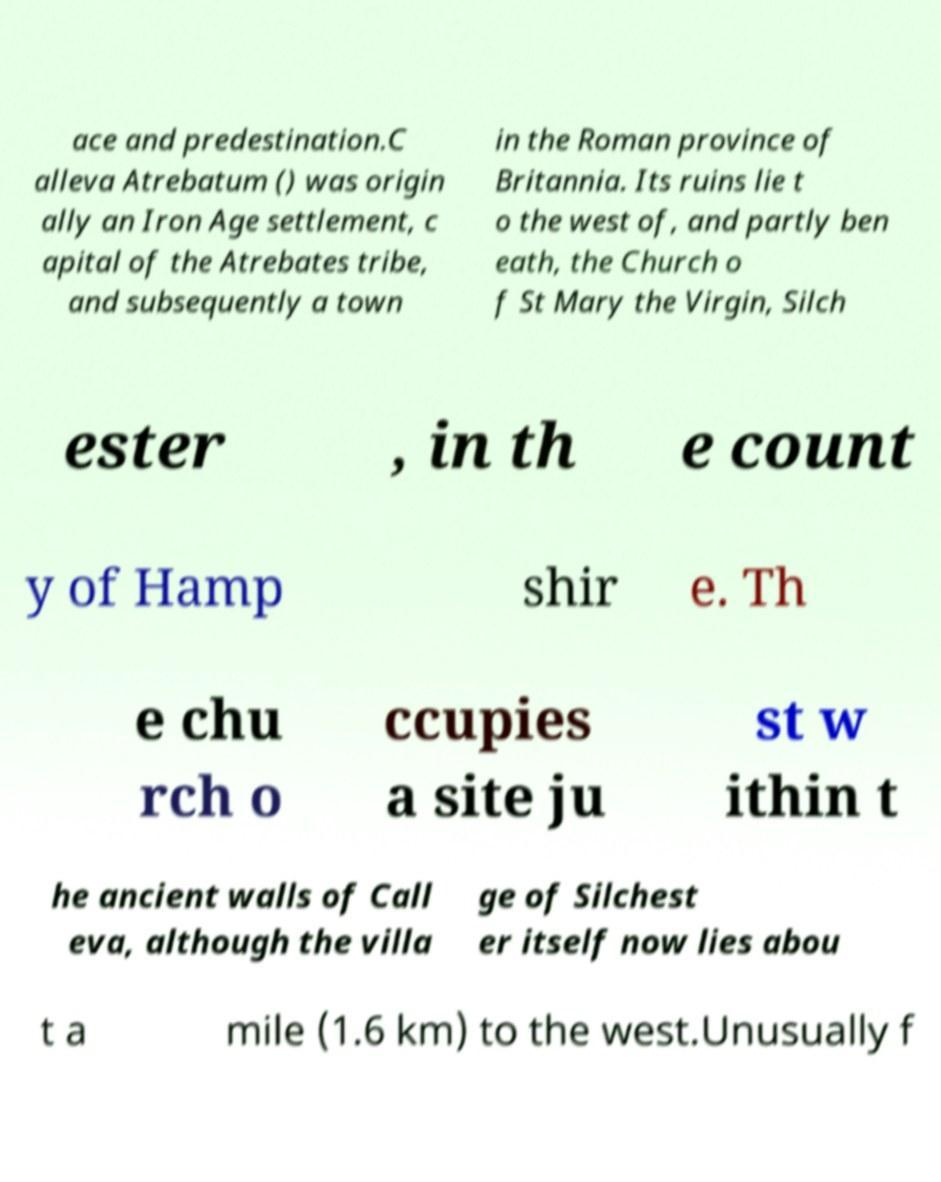Please read and relay the text visible in this image. What does it say? ace and predestination.C alleva Atrebatum () was origin ally an Iron Age settlement, c apital of the Atrebates tribe, and subsequently a town in the Roman province of Britannia. Its ruins lie t o the west of, and partly ben eath, the Church o f St Mary the Virgin, Silch ester , in th e count y of Hamp shir e. Th e chu rch o ccupies a site ju st w ithin t he ancient walls of Call eva, although the villa ge of Silchest er itself now lies abou t a mile (1.6 km) to the west.Unusually f 